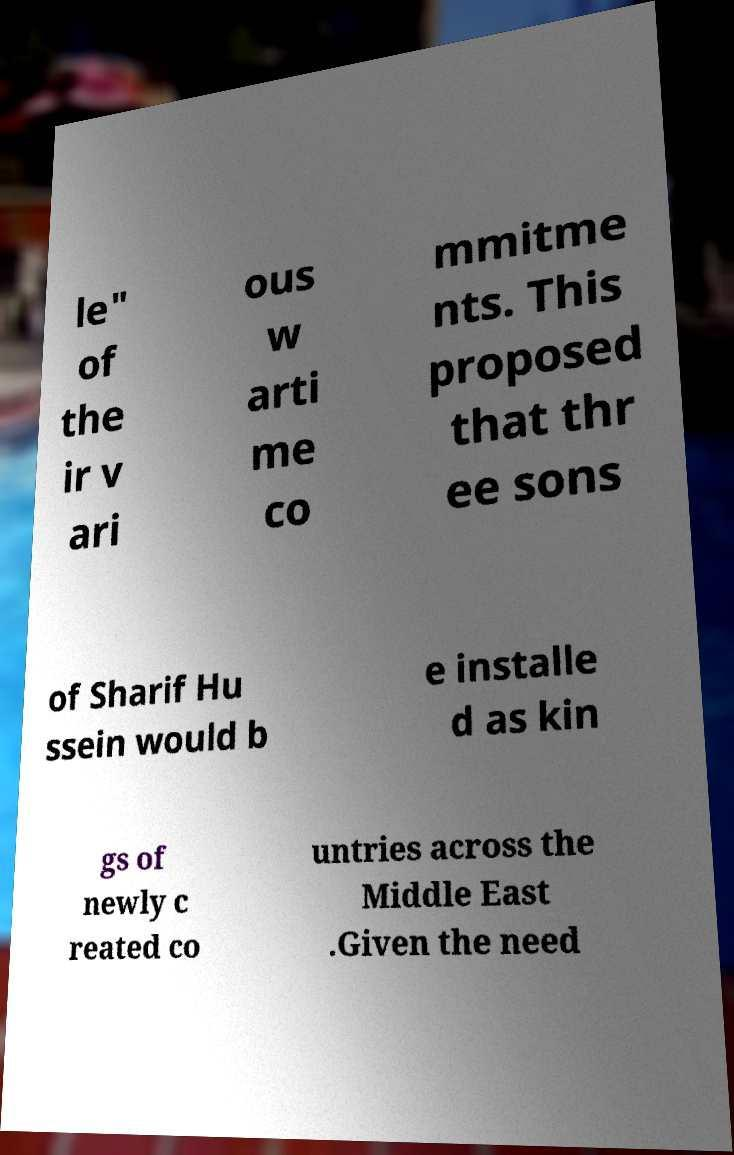There's text embedded in this image that I need extracted. Can you transcribe it verbatim? le" of the ir v ari ous w arti me co mmitme nts. This proposed that thr ee sons of Sharif Hu ssein would b e installe d as kin gs of newly c reated co untries across the Middle East .Given the need 